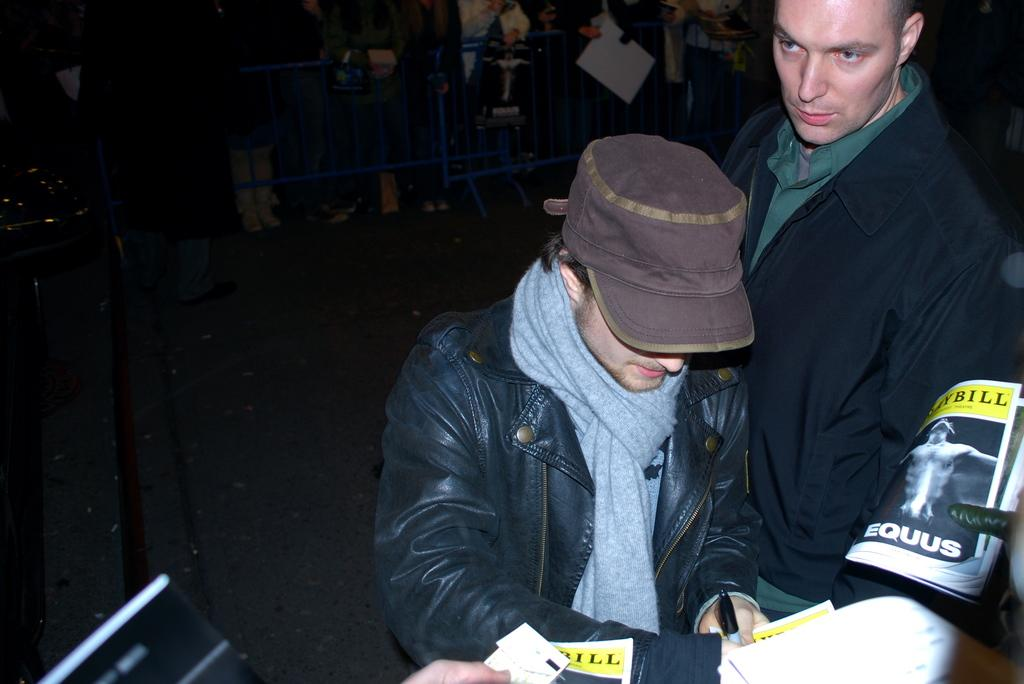What is the man in the image wearing? The man is wearing a coat, a cap, and a scarf. Can you describe the other person in the image? There is another person on the right side of the image, but their clothing is not mentioned in the facts. What can be seen in the background of the image? There are people standing in the background of the image. What type of bomb can be seen in the image? There is no bomb present in the image. How low is the order of the man in the image? There is no mention of an order or ranking in the image, so it cannot be determined. 